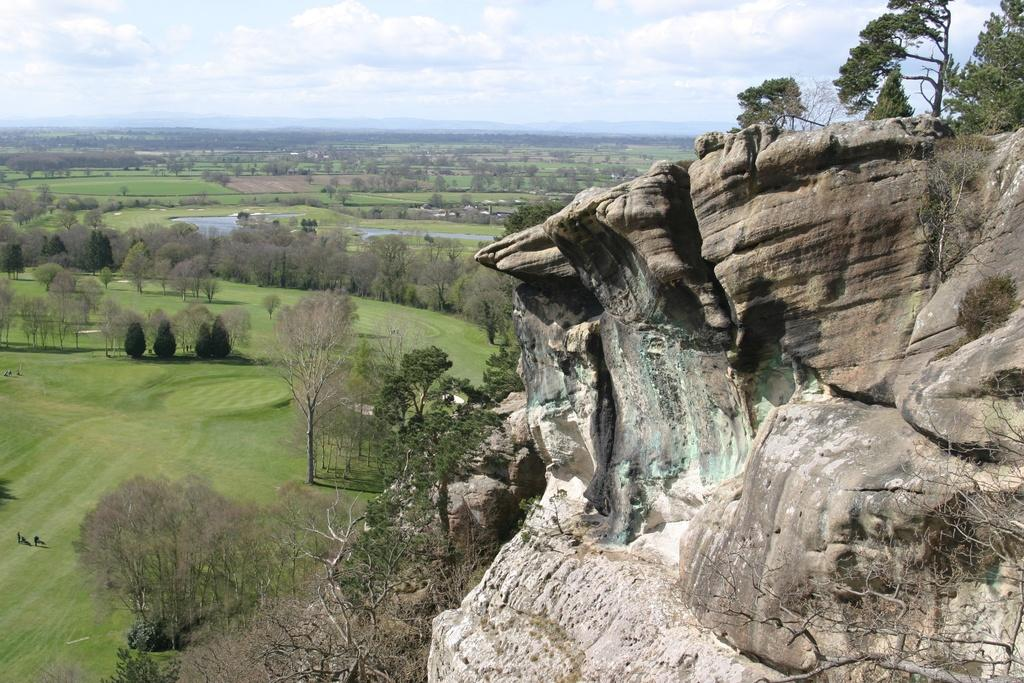What type of view is depicted in the image? The image is an aerial view. What geographical feature can be seen in the image? There is a hill in the image. What type of vegetation is present in the image? There are trees, grass, and plants in the image. What natural element is visible in the image? Water is visible in the image. What is visible in the sky in the image? The sky is visible in the image, and clouds are present. What type of pie is being served on the hill in the image? There is no pie present in the image; it is an aerial view of a landscape with a hill, trees, grass, plants, water, and a sky with clouds. What type of tank is visible in the image? There is no tank present in the image; it is a landscape with natural elements and no man-made structures or vehicles. 